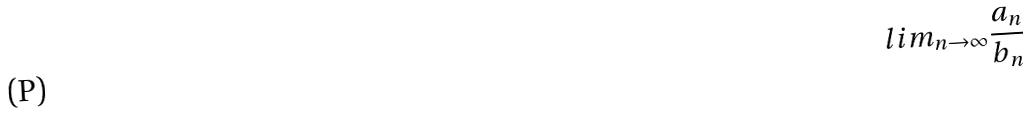<formula> <loc_0><loc_0><loc_500><loc_500>l i m _ { n \rightarrow \infty } \frac { a _ { n } } { b _ { n } }</formula> 